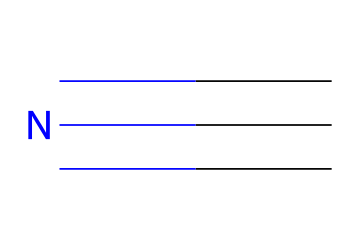What is the chemical name of the compound represented by this structure? The SMILES representation "C#N" corresponds to hydrogen cyanide, which is the common name for the chemical with this structure.
Answer: hydrogen cyanide How many total atoms are present in this molecule? The structure consists of one carbon atom (C) and one nitrogen atom (N), leading to a total of two atoms.
Answer: 2 What functional group is present in this nitrile? The presence of the triple bond between carbon and nitrogen indicates that this molecule contains a nitrile functional group, characterized by the -C≡N bond.
Answer: nitrile Does this chemical have a linear molecular geometry? The triple bond between the carbon and nitrogen atoms, along with the absence of lone pairs on either atom, creates a linear molecular geometry as per VSEPR theory.
Answer: yes What is the degree of unsaturation in this molecule? The triple bond contributes to the degree of unsaturation; thus, the compound has one degree of unsaturation based on the presence of this triple bond.
Answer: 1 What element is denoted by "N" in this structure? The letter "N" in the SMILES notation represents nitrogen, an essential element in the molecular structure of hydrogen cyanide.
Answer: nitrogen 